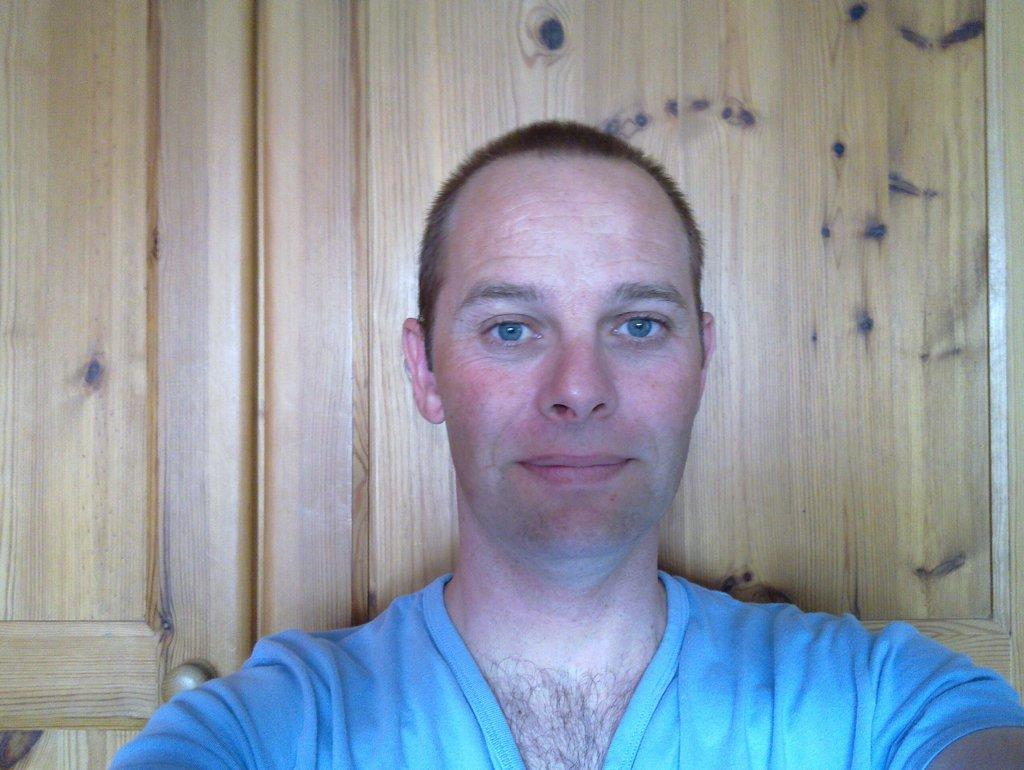What is the main subject of the image? There is a person standing in the image. Can you describe any other elements in the image? There is a door visible in the image. What color is the grape that the person is holding in the image? There is no grape present in the image, and the person is not holding anything. 